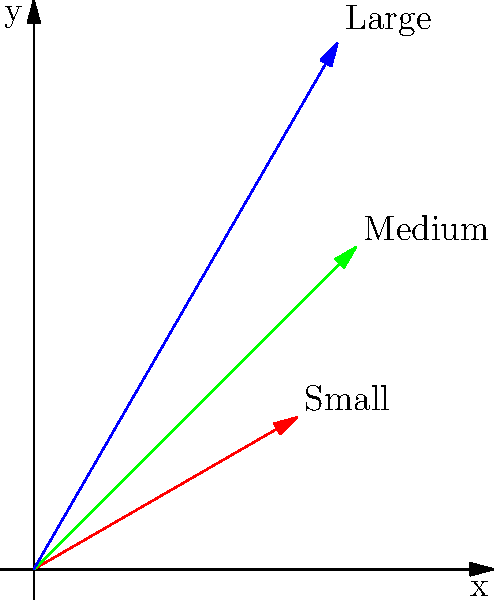In your dog training classes, you're discussing leash control for different dog sizes. The polar graph shows leash lengths and angles for small, medium, and large dogs. If the length of the leash for the medium dog is 3 meters at an angle of $\frac{\pi}{4}$ radians, what are the Cartesian coordinates $(x, y)$ of the end of the leash to the nearest tenth of a meter? To find the Cartesian coordinates from polar coordinates, we use the following formulas:

1) $x = r \cos(\theta)$
2) $y = r \sin(\theta)$

Given:
- $r = 3$ meters (length of the leash for medium dog)
- $\theta = \frac{\pi}{4}$ radians

Step 1: Calculate x-coordinate
$x = r \cos(\theta) = 3 \cos(\frac{\pi}{4})$
$\cos(\frac{\pi}{4}) = \frac{\sqrt{2}}{2}$
$x = 3 \cdot \frac{\sqrt{2}}{2} = \frac{3\sqrt{2}}{2} \approx 2.1$ meters

Step 2: Calculate y-coordinate
$y = r \sin(\theta) = 3 \sin(\frac{\pi}{4})$
$\sin(\frac{\pi}{4}) = \frac{\sqrt{2}}{2}$
$y = 3 \cdot \frac{\sqrt{2}}{2} = \frac{3\sqrt{2}}{2} \approx 2.1$ meters

Therefore, the Cartesian coordinates to the nearest tenth of a meter are (2.1, 2.1).
Answer: (2.1, 2.1) 